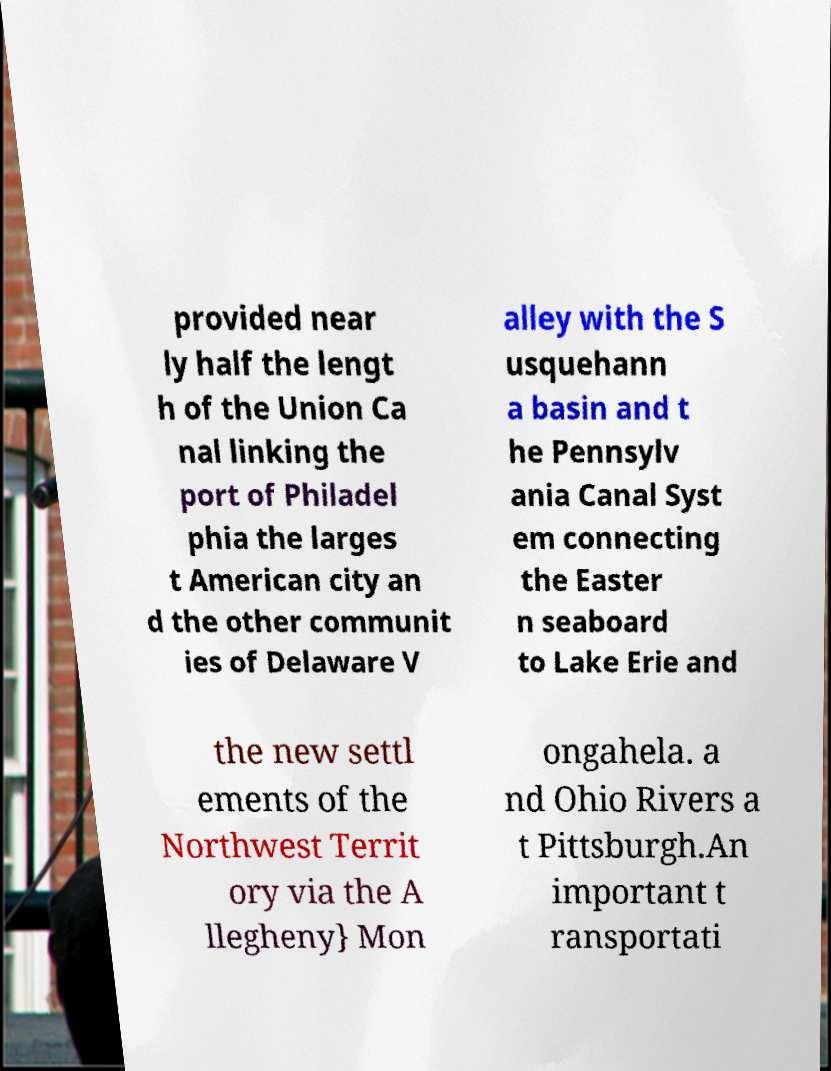Can you accurately transcribe the text from the provided image for me? provided near ly half the lengt h of the Union Ca nal linking the port of Philadel phia the larges t American city an d the other communit ies of Delaware V alley with the S usquehann a basin and t he Pennsylv ania Canal Syst em connecting the Easter n seaboard to Lake Erie and the new settl ements of the Northwest Territ ory via the A llegheny} Mon ongahela. a nd Ohio Rivers a t Pittsburgh.An important t ransportati 